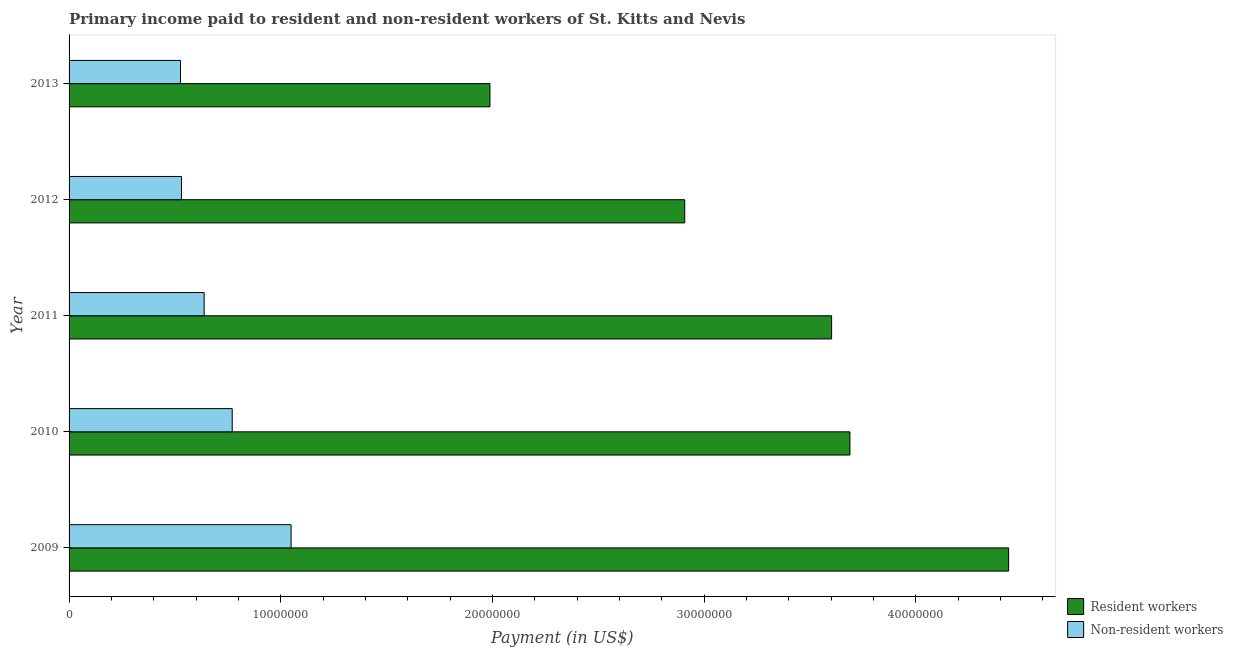How many bars are there on the 5th tick from the top?
Keep it short and to the point. 2. In how many cases, is the number of bars for a given year not equal to the number of legend labels?
Ensure brevity in your answer.  0. What is the payment made to non-resident workers in 2010?
Offer a terse response. 7.71e+06. Across all years, what is the maximum payment made to non-resident workers?
Provide a succinct answer. 1.05e+07. Across all years, what is the minimum payment made to resident workers?
Ensure brevity in your answer.  1.99e+07. What is the total payment made to resident workers in the graph?
Your answer should be compact. 1.66e+08. What is the difference between the payment made to non-resident workers in 2010 and that in 2013?
Provide a short and direct response. 2.44e+06. What is the difference between the payment made to non-resident workers in 2010 and the payment made to resident workers in 2012?
Your response must be concise. -2.14e+07. What is the average payment made to resident workers per year?
Provide a short and direct response. 3.33e+07. In the year 2012, what is the difference between the payment made to resident workers and payment made to non-resident workers?
Provide a short and direct response. 2.38e+07. What is the ratio of the payment made to non-resident workers in 2011 to that in 2012?
Ensure brevity in your answer.  1.2. Is the difference between the payment made to non-resident workers in 2009 and 2013 greater than the difference between the payment made to resident workers in 2009 and 2013?
Give a very brief answer. No. What is the difference between the highest and the second highest payment made to resident workers?
Your answer should be very brief. 7.50e+06. What is the difference between the highest and the lowest payment made to non-resident workers?
Provide a succinct answer. 5.23e+06. In how many years, is the payment made to resident workers greater than the average payment made to resident workers taken over all years?
Provide a succinct answer. 3. Is the sum of the payment made to resident workers in 2010 and 2013 greater than the maximum payment made to non-resident workers across all years?
Your answer should be compact. Yes. What does the 2nd bar from the top in 2012 represents?
Your answer should be compact. Resident workers. What does the 2nd bar from the bottom in 2011 represents?
Give a very brief answer. Non-resident workers. Are all the bars in the graph horizontal?
Provide a short and direct response. Yes. Does the graph contain any zero values?
Offer a terse response. No. What is the title of the graph?
Offer a terse response. Primary income paid to resident and non-resident workers of St. Kitts and Nevis. Does "Lower secondary rate" appear as one of the legend labels in the graph?
Ensure brevity in your answer.  No. What is the label or title of the X-axis?
Your answer should be compact. Payment (in US$). What is the Payment (in US$) in Resident workers in 2009?
Make the answer very short. 4.44e+07. What is the Payment (in US$) in Non-resident workers in 2009?
Your answer should be very brief. 1.05e+07. What is the Payment (in US$) in Resident workers in 2010?
Offer a very short reply. 3.69e+07. What is the Payment (in US$) of Non-resident workers in 2010?
Offer a very short reply. 7.71e+06. What is the Payment (in US$) in Resident workers in 2011?
Your answer should be very brief. 3.60e+07. What is the Payment (in US$) in Non-resident workers in 2011?
Your response must be concise. 6.38e+06. What is the Payment (in US$) in Resident workers in 2012?
Your answer should be compact. 2.91e+07. What is the Payment (in US$) of Non-resident workers in 2012?
Keep it short and to the point. 5.31e+06. What is the Payment (in US$) in Resident workers in 2013?
Your response must be concise. 1.99e+07. What is the Payment (in US$) in Non-resident workers in 2013?
Your answer should be very brief. 5.26e+06. Across all years, what is the maximum Payment (in US$) in Resident workers?
Give a very brief answer. 4.44e+07. Across all years, what is the maximum Payment (in US$) of Non-resident workers?
Offer a very short reply. 1.05e+07. Across all years, what is the minimum Payment (in US$) in Resident workers?
Ensure brevity in your answer.  1.99e+07. Across all years, what is the minimum Payment (in US$) in Non-resident workers?
Your response must be concise. 5.26e+06. What is the total Payment (in US$) in Resident workers in the graph?
Offer a very short reply. 1.66e+08. What is the total Payment (in US$) in Non-resident workers in the graph?
Provide a short and direct response. 3.52e+07. What is the difference between the Payment (in US$) of Resident workers in 2009 and that in 2010?
Offer a very short reply. 7.50e+06. What is the difference between the Payment (in US$) of Non-resident workers in 2009 and that in 2010?
Provide a short and direct response. 2.78e+06. What is the difference between the Payment (in US$) of Resident workers in 2009 and that in 2011?
Your answer should be very brief. 8.36e+06. What is the difference between the Payment (in US$) of Non-resident workers in 2009 and that in 2011?
Provide a short and direct response. 4.11e+06. What is the difference between the Payment (in US$) in Resident workers in 2009 and that in 2012?
Your answer should be very brief. 1.53e+07. What is the difference between the Payment (in US$) in Non-resident workers in 2009 and that in 2012?
Make the answer very short. 5.18e+06. What is the difference between the Payment (in US$) of Resident workers in 2009 and that in 2013?
Your answer should be very brief. 2.45e+07. What is the difference between the Payment (in US$) in Non-resident workers in 2009 and that in 2013?
Your answer should be very brief. 5.23e+06. What is the difference between the Payment (in US$) of Resident workers in 2010 and that in 2011?
Offer a terse response. 8.65e+05. What is the difference between the Payment (in US$) of Non-resident workers in 2010 and that in 2011?
Your response must be concise. 1.33e+06. What is the difference between the Payment (in US$) of Resident workers in 2010 and that in 2012?
Your answer should be compact. 7.81e+06. What is the difference between the Payment (in US$) of Non-resident workers in 2010 and that in 2012?
Offer a terse response. 2.40e+06. What is the difference between the Payment (in US$) in Resident workers in 2010 and that in 2013?
Give a very brief answer. 1.70e+07. What is the difference between the Payment (in US$) in Non-resident workers in 2010 and that in 2013?
Give a very brief answer. 2.44e+06. What is the difference between the Payment (in US$) in Resident workers in 2011 and that in 2012?
Keep it short and to the point. 6.94e+06. What is the difference between the Payment (in US$) of Non-resident workers in 2011 and that in 2012?
Your answer should be very brief. 1.07e+06. What is the difference between the Payment (in US$) in Resident workers in 2011 and that in 2013?
Your response must be concise. 1.61e+07. What is the difference between the Payment (in US$) of Non-resident workers in 2011 and that in 2013?
Offer a terse response. 1.12e+06. What is the difference between the Payment (in US$) of Resident workers in 2012 and that in 2013?
Make the answer very short. 9.20e+06. What is the difference between the Payment (in US$) of Non-resident workers in 2012 and that in 2013?
Offer a very short reply. 4.69e+04. What is the difference between the Payment (in US$) in Resident workers in 2009 and the Payment (in US$) in Non-resident workers in 2010?
Offer a very short reply. 3.67e+07. What is the difference between the Payment (in US$) in Resident workers in 2009 and the Payment (in US$) in Non-resident workers in 2011?
Your response must be concise. 3.80e+07. What is the difference between the Payment (in US$) in Resident workers in 2009 and the Payment (in US$) in Non-resident workers in 2012?
Your response must be concise. 3.91e+07. What is the difference between the Payment (in US$) in Resident workers in 2009 and the Payment (in US$) in Non-resident workers in 2013?
Provide a short and direct response. 3.91e+07. What is the difference between the Payment (in US$) in Resident workers in 2010 and the Payment (in US$) in Non-resident workers in 2011?
Your answer should be compact. 3.05e+07. What is the difference between the Payment (in US$) in Resident workers in 2010 and the Payment (in US$) in Non-resident workers in 2012?
Offer a terse response. 3.16e+07. What is the difference between the Payment (in US$) of Resident workers in 2010 and the Payment (in US$) of Non-resident workers in 2013?
Offer a very short reply. 3.16e+07. What is the difference between the Payment (in US$) in Resident workers in 2011 and the Payment (in US$) in Non-resident workers in 2012?
Your response must be concise. 3.07e+07. What is the difference between the Payment (in US$) of Resident workers in 2011 and the Payment (in US$) of Non-resident workers in 2013?
Your answer should be very brief. 3.08e+07. What is the difference between the Payment (in US$) of Resident workers in 2012 and the Payment (in US$) of Non-resident workers in 2013?
Ensure brevity in your answer.  2.38e+07. What is the average Payment (in US$) of Resident workers per year?
Your answer should be very brief. 3.33e+07. What is the average Payment (in US$) in Non-resident workers per year?
Give a very brief answer. 7.03e+06. In the year 2009, what is the difference between the Payment (in US$) of Resident workers and Payment (in US$) of Non-resident workers?
Offer a terse response. 3.39e+07. In the year 2010, what is the difference between the Payment (in US$) in Resident workers and Payment (in US$) in Non-resident workers?
Provide a succinct answer. 2.92e+07. In the year 2011, what is the difference between the Payment (in US$) of Resident workers and Payment (in US$) of Non-resident workers?
Provide a succinct answer. 2.96e+07. In the year 2012, what is the difference between the Payment (in US$) of Resident workers and Payment (in US$) of Non-resident workers?
Ensure brevity in your answer.  2.38e+07. In the year 2013, what is the difference between the Payment (in US$) of Resident workers and Payment (in US$) of Non-resident workers?
Provide a short and direct response. 1.46e+07. What is the ratio of the Payment (in US$) in Resident workers in 2009 to that in 2010?
Make the answer very short. 1.2. What is the ratio of the Payment (in US$) of Non-resident workers in 2009 to that in 2010?
Your response must be concise. 1.36. What is the ratio of the Payment (in US$) of Resident workers in 2009 to that in 2011?
Give a very brief answer. 1.23. What is the ratio of the Payment (in US$) of Non-resident workers in 2009 to that in 2011?
Provide a short and direct response. 1.64. What is the ratio of the Payment (in US$) of Resident workers in 2009 to that in 2012?
Provide a short and direct response. 1.53. What is the ratio of the Payment (in US$) of Non-resident workers in 2009 to that in 2012?
Make the answer very short. 1.98. What is the ratio of the Payment (in US$) in Resident workers in 2009 to that in 2013?
Keep it short and to the point. 2.23. What is the ratio of the Payment (in US$) of Non-resident workers in 2009 to that in 2013?
Ensure brevity in your answer.  1.99. What is the ratio of the Payment (in US$) in Resident workers in 2010 to that in 2011?
Make the answer very short. 1.02. What is the ratio of the Payment (in US$) in Non-resident workers in 2010 to that in 2011?
Make the answer very short. 1.21. What is the ratio of the Payment (in US$) of Resident workers in 2010 to that in 2012?
Give a very brief answer. 1.27. What is the ratio of the Payment (in US$) in Non-resident workers in 2010 to that in 2012?
Offer a terse response. 1.45. What is the ratio of the Payment (in US$) in Resident workers in 2010 to that in 2013?
Give a very brief answer. 1.86. What is the ratio of the Payment (in US$) of Non-resident workers in 2010 to that in 2013?
Give a very brief answer. 1.46. What is the ratio of the Payment (in US$) in Resident workers in 2011 to that in 2012?
Provide a succinct answer. 1.24. What is the ratio of the Payment (in US$) of Non-resident workers in 2011 to that in 2012?
Give a very brief answer. 1.2. What is the ratio of the Payment (in US$) of Resident workers in 2011 to that in 2013?
Your answer should be very brief. 1.81. What is the ratio of the Payment (in US$) in Non-resident workers in 2011 to that in 2013?
Your response must be concise. 1.21. What is the ratio of the Payment (in US$) in Resident workers in 2012 to that in 2013?
Provide a succinct answer. 1.46. What is the ratio of the Payment (in US$) in Non-resident workers in 2012 to that in 2013?
Provide a succinct answer. 1.01. What is the difference between the highest and the second highest Payment (in US$) of Resident workers?
Provide a succinct answer. 7.50e+06. What is the difference between the highest and the second highest Payment (in US$) in Non-resident workers?
Give a very brief answer. 2.78e+06. What is the difference between the highest and the lowest Payment (in US$) of Resident workers?
Give a very brief answer. 2.45e+07. What is the difference between the highest and the lowest Payment (in US$) in Non-resident workers?
Give a very brief answer. 5.23e+06. 